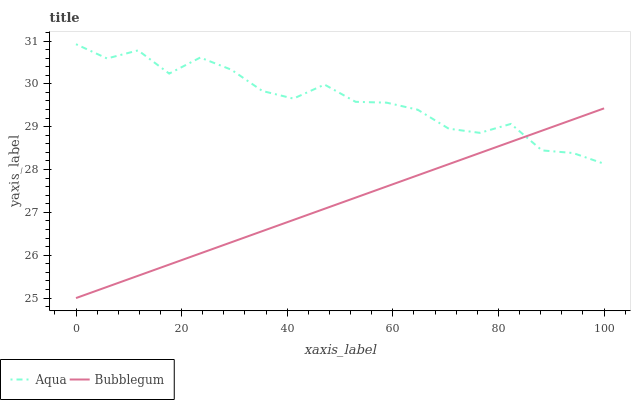Does Bubblegum have the minimum area under the curve?
Answer yes or no. Yes. Does Aqua have the maximum area under the curve?
Answer yes or no. Yes. Does Bubblegum have the maximum area under the curve?
Answer yes or no. No. Is Bubblegum the smoothest?
Answer yes or no. Yes. Is Aqua the roughest?
Answer yes or no. Yes. Is Bubblegum the roughest?
Answer yes or no. No. Does Bubblegum have the lowest value?
Answer yes or no. Yes. Does Aqua have the highest value?
Answer yes or no. Yes. Does Bubblegum have the highest value?
Answer yes or no. No. Does Bubblegum intersect Aqua?
Answer yes or no. Yes. Is Bubblegum less than Aqua?
Answer yes or no. No. Is Bubblegum greater than Aqua?
Answer yes or no. No. 